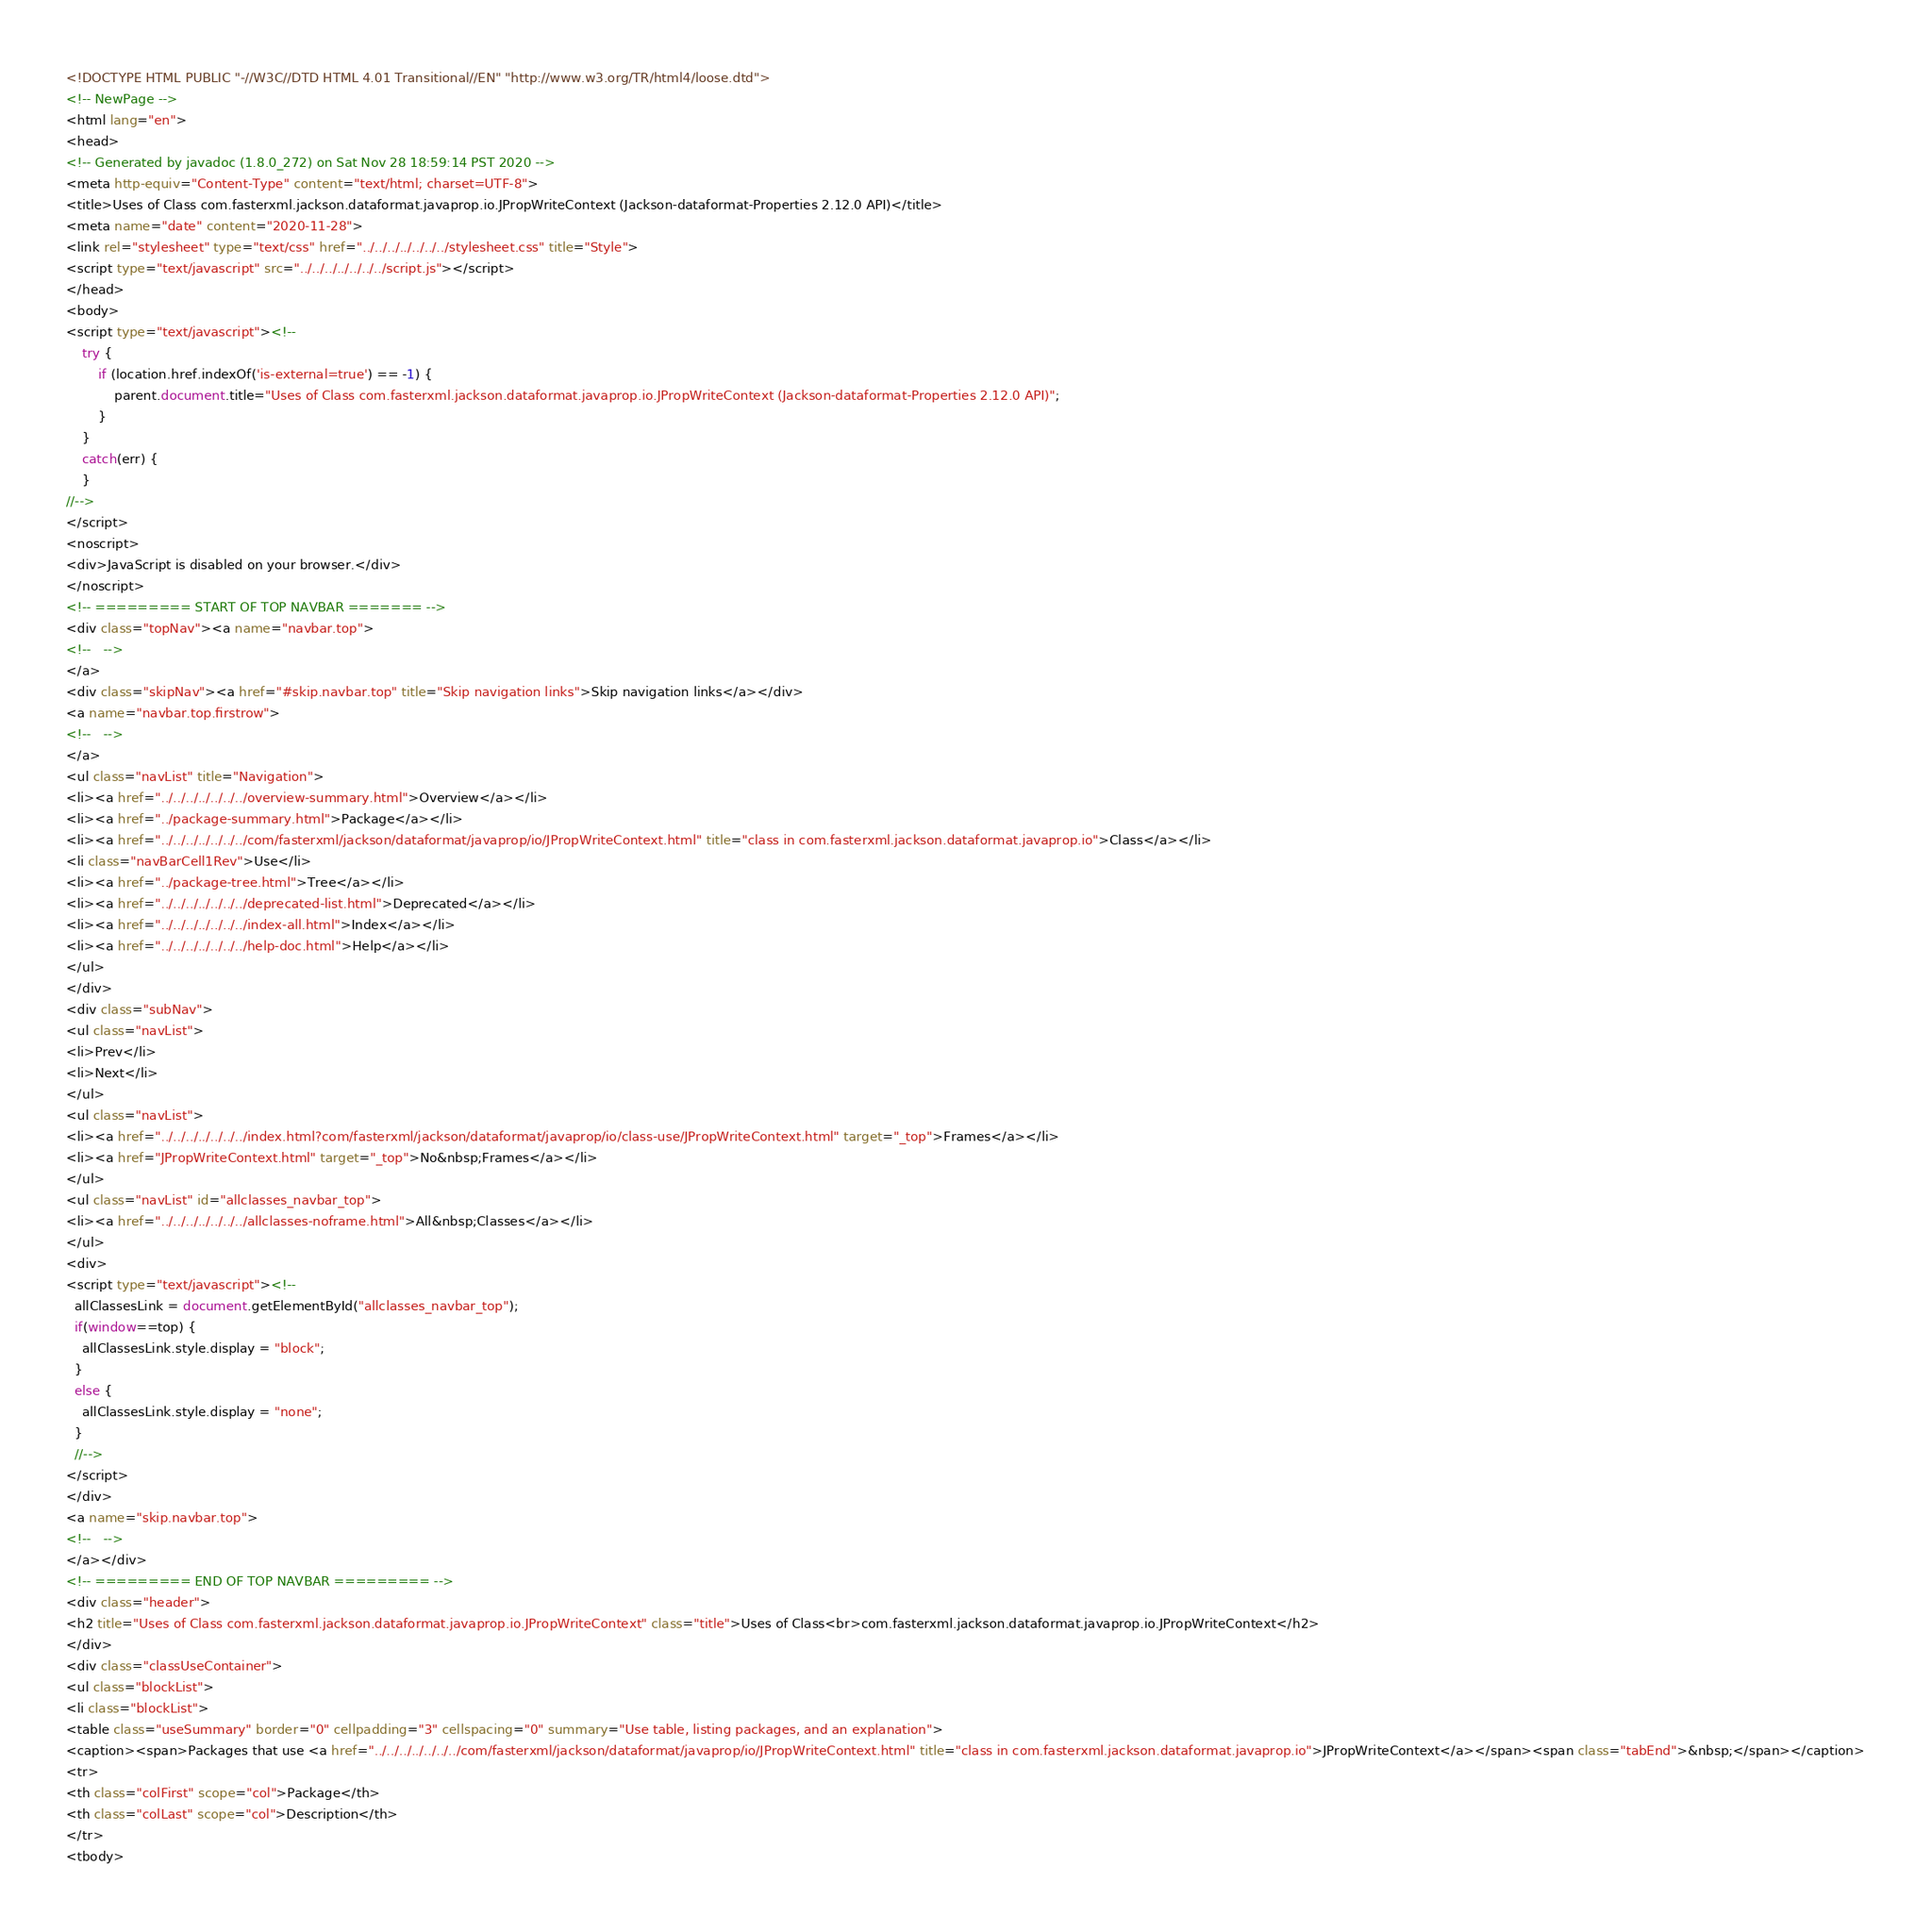Convert code to text. <code><loc_0><loc_0><loc_500><loc_500><_HTML_><!DOCTYPE HTML PUBLIC "-//W3C//DTD HTML 4.01 Transitional//EN" "http://www.w3.org/TR/html4/loose.dtd">
<!-- NewPage -->
<html lang="en">
<head>
<!-- Generated by javadoc (1.8.0_272) on Sat Nov 28 18:59:14 PST 2020 -->
<meta http-equiv="Content-Type" content="text/html; charset=UTF-8">
<title>Uses of Class com.fasterxml.jackson.dataformat.javaprop.io.JPropWriteContext (Jackson-dataformat-Properties 2.12.0 API)</title>
<meta name="date" content="2020-11-28">
<link rel="stylesheet" type="text/css" href="../../../../../../../stylesheet.css" title="Style">
<script type="text/javascript" src="../../../../../../../script.js"></script>
</head>
<body>
<script type="text/javascript"><!--
    try {
        if (location.href.indexOf('is-external=true') == -1) {
            parent.document.title="Uses of Class com.fasterxml.jackson.dataformat.javaprop.io.JPropWriteContext (Jackson-dataformat-Properties 2.12.0 API)";
        }
    }
    catch(err) {
    }
//-->
</script>
<noscript>
<div>JavaScript is disabled on your browser.</div>
</noscript>
<!-- ========= START OF TOP NAVBAR ======= -->
<div class="topNav"><a name="navbar.top">
<!--   -->
</a>
<div class="skipNav"><a href="#skip.navbar.top" title="Skip navigation links">Skip navigation links</a></div>
<a name="navbar.top.firstrow">
<!--   -->
</a>
<ul class="navList" title="Navigation">
<li><a href="../../../../../../../overview-summary.html">Overview</a></li>
<li><a href="../package-summary.html">Package</a></li>
<li><a href="../../../../../../../com/fasterxml/jackson/dataformat/javaprop/io/JPropWriteContext.html" title="class in com.fasterxml.jackson.dataformat.javaprop.io">Class</a></li>
<li class="navBarCell1Rev">Use</li>
<li><a href="../package-tree.html">Tree</a></li>
<li><a href="../../../../../../../deprecated-list.html">Deprecated</a></li>
<li><a href="../../../../../../../index-all.html">Index</a></li>
<li><a href="../../../../../../../help-doc.html">Help</a></li>
</ul>
</div>
<div class="subNav">
<ul class="navList">
<li>Prev</li>
<li>Next</li>
</ul>
<ul class="navList">
<li><a href="../../../../../../../index.html?com/fasterxml/jackson/dataformat/javaprop/io/class-use/JPropWriteContext.html" target="_top">Frames</a></li>
<li><a href="JPropWriteContext.html" target="_top">No&nbsp;Frames</a></li>
</ul>
<ul class="navList" id="allclasses_navbar_top">
<li><a href="../../../../../../../allclasses-noframe.html">All&nbsp;Classes</a></li>
</ul>
<div>
<script type="text/javascript"><!--
  allClassesLink = document.getElementById("allclasses_navbar_top");
  if(window==top) {
    allClassesLink.style.display = "block";
  }
  else {
    allClassesLink.style.display = "none";
  }
  //-->
</script>
</div>
<a name="skip.navbar.top">
<!--   -->
</a></div>
<!-- ========= END OF TOP NAVBAR ========= -->
<div class="header">
<h2 title="Uses of Class com.fasterxml.jackson.dataformat.javaprop.io.JPropWriteContext" class="title">Uses of Class<br>com.fasterxml.jackson.dataformat.javaprop.io.JPropWriteContext</h2>
</div>
<div class="classUseContainer">
<ul class="blockList">
<li class="blockList">
<table class="useSummary" border="0" cellpadding="3" cellspacing="0" summary="Use table, listing packages, and an explanation">
<caption><span>Packages that use <a href="../../../../../../../com/fasterxml/jackson/dataformat/javaprop/io/JPropWriteContext.html" title="class in com.fasterxml.jackson.dataformat.javaprop.io">JPropWriteContext</a></span><span class="tabEnd">&nbsp;</span></caption>
<tr>
<th class="colFirst" scope="col">Package</th>
<th class="colLast" scope="col">Description</th>
</tr>
<tbody></code> 